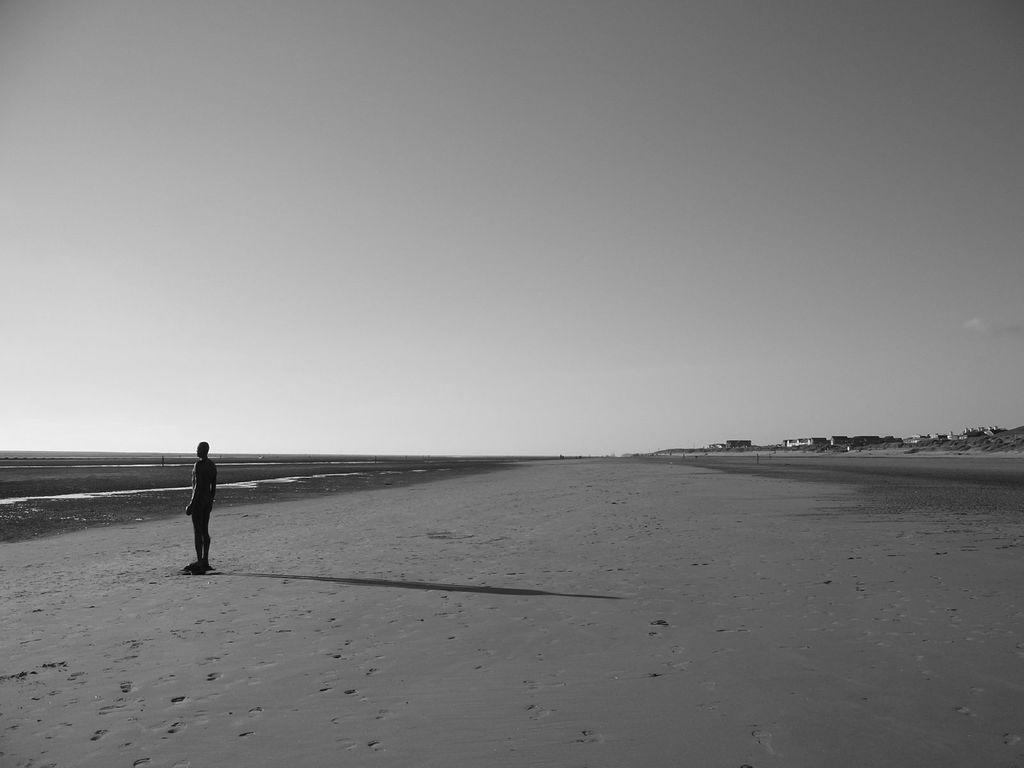What is the color scheme of the image? The image is black and white. What is the person in the image standing on? The person is standing on the sand. What can be seen in the background of the image? There are houses and the sky visible in the background. How many dinosaurs can be seen in the image? There are no dinosaurs present in the image. What type of self-reflection can be observed in the image? There is no self-reflection visible in the image, as it is a black and white photograph of a person standing on the sand with houses and the sky in the background. 